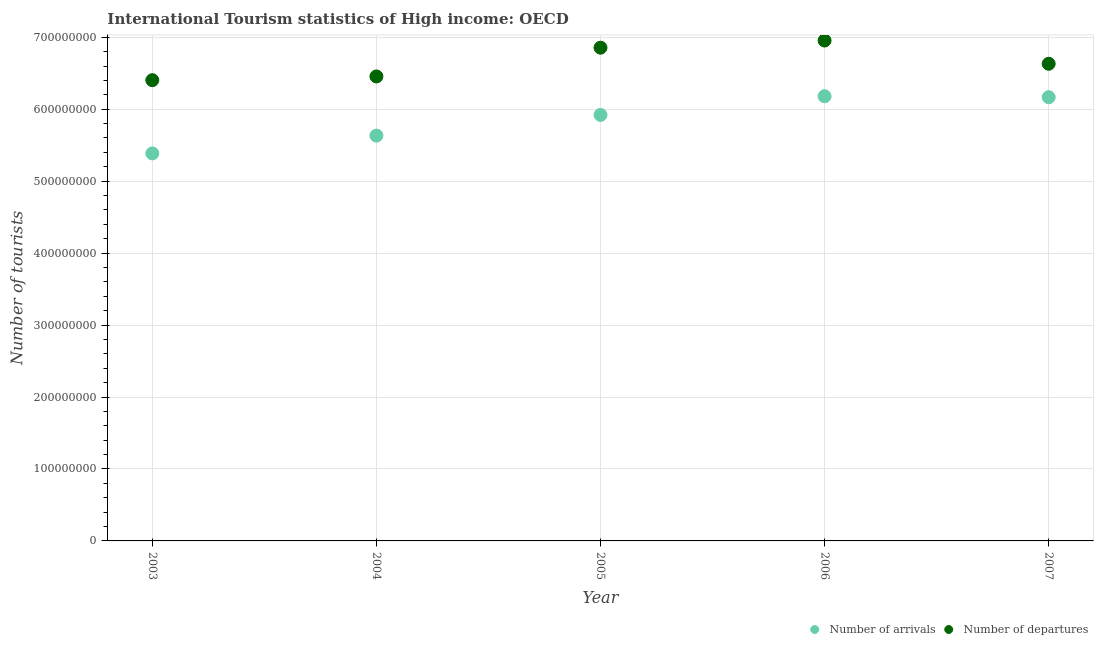How many different coloured dotlines are there?
Ensure brevity in your answer.  2. Is the number of dotlines equal to the number of legend labels?
Give a very brief answer. Yes. What is the number of tourist arrivals in 2007?
Your response must be concise. 6.17e+08. Across all years, what is the maximum number of tourist arrivals?
Provide a succinct answer. 6.18e+08. Across all years, what is the minimum number of tourist arrivals?
Make the answer very short. 5.39e+08. In which year was the number of tourist departures minimum?
Give a very brief answer. 2003. What is the total number of tourist arrivals in the graph?
Ensure brevity in your answer.  2.93e+09. What is the difference between the number of tourist departures in 2004 and that in 2006?
Offer a very short reply. -4.99e+07. What is the difference between the number of tourist arrivals in 2007 and the number of tourist departures in 2006?
Offer a terse response. -7.88e+07. What is the average number of tourist departures per year?
Keep it short and to the point. 6.66e+08. In the year 2005, what is the difference between the number of tourist departures and number of tourist arrivals?
Your answer should be compact. 9.34e+07. In how many years, is the number of tourist departures greater than 680000000?
Offer a terse response. 2. What is the ratio of the number of tourist arrivals in 2005 to that in 2007?
Provide a succinct answer. 0.96. Is the number of tourist departures in 2005 less than that in 2007?
Ensure brevity in your answer.  No. Is the difference between the number of tourist departures in 2004 and 2007 greater than the difference between the number of tourist arrivals in 2004 and 2007?
Offer a terse response. Yes. What is the difference between the highest and the second highest number of tourist departures?
Your response must be concise. 9.97e+06. What is the difference between the highest and the lowest number of tourist departures?
Make the answer very short. 5.51e+07. Is the sum of the number of tourist departures in 2004 and 2006 greater than the maximum number of tourist arrivals across all years?
Offer a terse response. Yes. How many years are there in the graph?
Ensure brevity in your answer.  5. Are the values on the major ticks of Y-axis written in scientific E-notation?
Keep it short and to the point. No. Where does the legend appear in the graph?
Offer a terse response. Bottom right. How are the legend labels stacked?
Your answer should be compact. Horizontal. What is the title of the graph?
Provide a short and direct response. International Tourism statistics of High income: OECD. Does "Working only" appear as one of the legend labels in the graph?
Ensure brevity in your answer.  No. What is the label or title of the Y-axis?
Make the answer very short. Number of tourists. What is the Number of tourists of Number of arrivals in 2003?
Ensure brevity in your answer.  5.39e+08. What is the Number of tourists of Number of departures in 2003?
Your answer should be compact. 6.40e+08. What is the Number of tourists of Number of arrivals in 2004?
Give a very brief answer. 5.63e+08. What is the Number of tourists in Number of departures in 2004?
Offer a terse response. 6.46e+08. What is the Number of tourists in Number of arrivals in 2005?
Offer a very short reply. 5.92e+08. What is the Number of tourists of Number of departures in 2005?
Provide a short and direct response. 6.85e+08. What is the Number of tourists of Number of arrivals in 2006?
Offer a very short reply. 6.18e+08. What is the Number of tourists in Number of departures in 2006?
Provide a succinct answer. 6.95e+08. What is the Number of tourists of Number of arrivals in 2007?
Offer a terse response. 6.17e+08. What is the Number of tourists in Number of departures in 2007?
Ensure brevity in your answer.  6.63e+08. Across all years, what is the maximum Number of tourists in Number of arrivals?
Your answer should be very brief. 6.18e+08. Across all years, what is the maximum Number of tourists in Number of departures?
Keep it short and to the point. 6.95e+08. Across all years, what is the minimum Number of tourists of Number of arrivals?
Give a very brief answer. 5.39e+08. Across all years, what is the minimum Number of tourists in Number of departures?
Your answer should be compact. 6.40e+08. What is the total Number of tourists in Number of arrivals in the graph?
Keep it short and to the point. 2.93e+09. What is the total Number of tourists of Number of departures in the graph?
Provide a short and direct response. 3.33e+09. What is the difference between the Number of tourists in Number of arrivals in 2003 and that in 2004?
Your answer should be compact. -2.47e+07. What is the difference between the Number of tourists in Number of departures in 2003 and that in 2004?
Offer a very short reply. -5.19e+06. What is the difference between the Number of tourists in Number of arrivals in 2003 and that in 2005?
Ensure brevity in your answer.  -5.35e+07. What is the difference between the Number of tourists of Number of departures in 2003 and that in 2005?
Your answer should be very brief. -4.51e+07. What is the difference between the Number of tourists of Number of arrivals in 2003 and that in 2006?
Your response must be concise. -7.95e+07. What is the difference between the Number of tourists in Number of departures in 2003 and that in 2006?
Offer a terse response. -5.51e+07. What is the difference between the Number of tourists of Number of arrivals in 2003 and that in 2007?
Your response must be concise. -7.81e+07. What is the difference between the Number of tourists in Number of departures in 2003 and that in 2007?
Offer a very short reply. -2.28e+07. What is the difference between the Number of tourists of Number of arrivals in 2004 and that in 2005?
Give a very brief answer. -2.87e+07. What is the difference between the Number of tourists of Number of departures in 2004 and that in 2005?
Keep it short and to the point. -3.99e+07. What is the difference between the Number of tourists of Number of arrivals in 2004 and that in 2006?
Provide a succinct answer. -5.47e+07. What is the difference between the Number of tourists of Number of departures in 2004 and that in 2006?
Provide a short and direct response. -4.99e+07. What is the difference between the Number of tourists in Number of arrivals in 2004 and that in 2007?
Offer a very short reply. -5.34e+07. What is the difference between the Number of tourists of Number of departures in 2004 and that in 2007?
Your answer should be compact. -1.76e+07. What is the difference between the Number of tourists of Number of arrivals in 2005 and that in 2006?
Make the answer very short. -2.60e+07. What is the difference between the Number of tourists of Number of departures in 2005 and that in 2006?
Your answer should be compact. -9.97e+06. What is the difference between the Number of tourists of Number of arrivals in 2005 and that in 2007?
Offer a terse response. -2.46e+07. What is the difference between the Number of tourists in Number of departures in 2005 and that in 2007?
Ensure brevity in your answer.  2.23e+07. What is the difference between the Number of tourists in Number of arrivals in 2006 and that in 2007?
Keep it short and to the point. 1.35e+06. What is the difference between the Number of tourists in Number of departures in 2006 and that in 2007?
Offer a very short reply. 3.23e+07. What is the difference between the Number of tourists in Number of arrivals in 2003 and the Number of tourists in Number of departures in 2004?
Provide a short and direct response. -1.07e+08. What is the difference between the Number of tourists of Number of arrivals in 2003 and the Number of tourists of Number of departures in 2005?
Your response must be concise. -1.47e+08. What is the difference between the Number of tourists of Number of arrivals in 2003 and the Number of tourists of Number of departures in 2006?
Offer a terse response. -1.57e+08. What is the difference between the Number of tourists in Number of arrivals in 2003 and the Number of tourists in Number of departures in 2007?
Offer a very short reply. -1.25e+08. What is the difference between the Number of tourists of Number of arrivals in 2004 and the Number of tourists of Number of departures in 2005?
Provide a short and direct response. -1.22e+08. What is the difference between the Number of tourists of Number of arrivals in 2004 and the Number of tourists of Number of departures in 2006?
Ensure brevity in your answer.  -1.32e+08. What is the difference between the Number of tourists of Number of arrivals in 2004 and the Number of tourists of Number of departures in 2007?
Give a very brief answer. -9.98e+07. What is the difference between the Number of tourists of Number of arrivals in 2005 and the Number of tourists of Number of departures in 2006?
Provide a short and direct response. -1.03e+08. What is the difference between the Number of tourists of Number of arrivals in 2005 and the Number of tourists of Number of departures in 2007?
Your response must be concise. -7.11e+07. What is the difference between the Number of tourists of Number of arrivals in 2006 and the Number of tourists of Number of departures in 2007?
Your answer should be very brief. -4.51e+07. What is the average Number of tourists of Number of arrivals per year?
Offer a terse response. 5.86e+08. What is the average Number of tourists in Number of departures per year?
Ensure brevity in your answer.  6.66e+08. In the year 2003, what is the difference between the Number of tourists of Number of arrivals and Number of tourists of Number of departures?
Keep it short and to the point. -1.02e+08. In the year 2004, what is the difference between the Number of tourists of Number of arrivals and Number of tourists of Number of departures?
Your answer should be very brief. -8.22e+07. In the year 2005, what is the difference between the Number of tourists of Number of arrivals and Number of tourists of Number of departures?
Your response must be concise. -9.34e+07. In the year 2006, what is the difference between the Number of tourists in Number of arrivals and Number of tourists in Number of departures?
Ensure brevity in your answer.  -7.74e+07. In the year 2007, what is the difference between the Number of tourists of Number of arrivals and Number of tourists of Number of departures?
Give a very brief answer. -4.65e+07. What is the ratio of the Number of tourists of Number of arrivals in 2003 to that in 2004?
Provide a succinct answer. 0.96. What is the ratio of the Number of tourists in Number of departures in 2003 to that in 2004?
Offer a very short reply. 0.99. What is the ratio of the Number of tourists in Number of arrivals in 2003 to that in 2005?
Keep it short and to the point. 0.91. What is the ratio of the Number of tourists in Number of departures in 2003 to that in 2005?
Make the answer very short. 0.93. What is the ratio of the Number of tourists in Number of arrivals in 2003 to that in 2006?
Your response must be concise. 0.87. What is the ratio of the Number of tourists in Number of departures in 2003 to that in 2006?
Ensure brevity in your answer.  0.92. What is the ratio of the Number of tourists in Number of arrivals in 2003 to that in 2007?
Provide a succinct answer. 0.87. What is the ratio of the Number of tourists in Number of departures in 2003 to that in 2007?
Offer a very short reply. 0.97. What is the ratio of the Number of tourists in Number of arrivals in 2004 to that in 2005?
Provide a succinct answer. 0.95. What is the ratio of the Number of tourists in Number of departures in 2004 to that in 2005?
Provide a short and direct response. 0.94. What is the ratio of the Number of tourists of Number of arrivals in 2004 to that in 2006?
Your answer should be very brief. 0.91. What is the ratio of the Number of tourists of Number of departures in 2004 to that in 2006?
Offer a terse response. 0.93. What is the ratio of the Number of tourists in Number of arrivals in 2004 to that in 2007?
Ensure brevity in your answer.  0.91. What is the ratio of the Number of tourists of Number of departures in 2004 to that in 2007?
Your answer should be very brief. 0.97. What is the ratio of the Number of tourists in Number of arrivals in 2005 to that in 2006?
Offer a terse response. 0.96. What is the ratio of the Number of tourists in Number of departures in 2005 to that in 2006?
Offer a terse response. 0.99. What is the ratio of the Number of tourists of Number of arrivals in 2005 to that in 2007?
Your response must be concise. 0.96. What is the ratio of the Number of tourists in Number of departures in 2005 to that in 2007?
Give a very brief answer. 1.03. What is the ratio of the Number of tourists in Number of departures in 2006 to that in 2007?
Provide a succinct answer. 1.05. What is the difference between the highest and the second highest Number of tourists of Number of arrivals?
Give a very brief answer. 1.35e+06. What is the difference between the highest and the second highest Number of tourists in Number of departures?
Your answer should be compact. 9.97e+06. What is the difference between the highest and the lowest Number of tourists in Number of arrivals?
Your response must be concise. 7.95e+07. What is the difference between the highest and the lowest Number of tourists of Number of departures?
Your answer should be compact. 5.51e+07. 